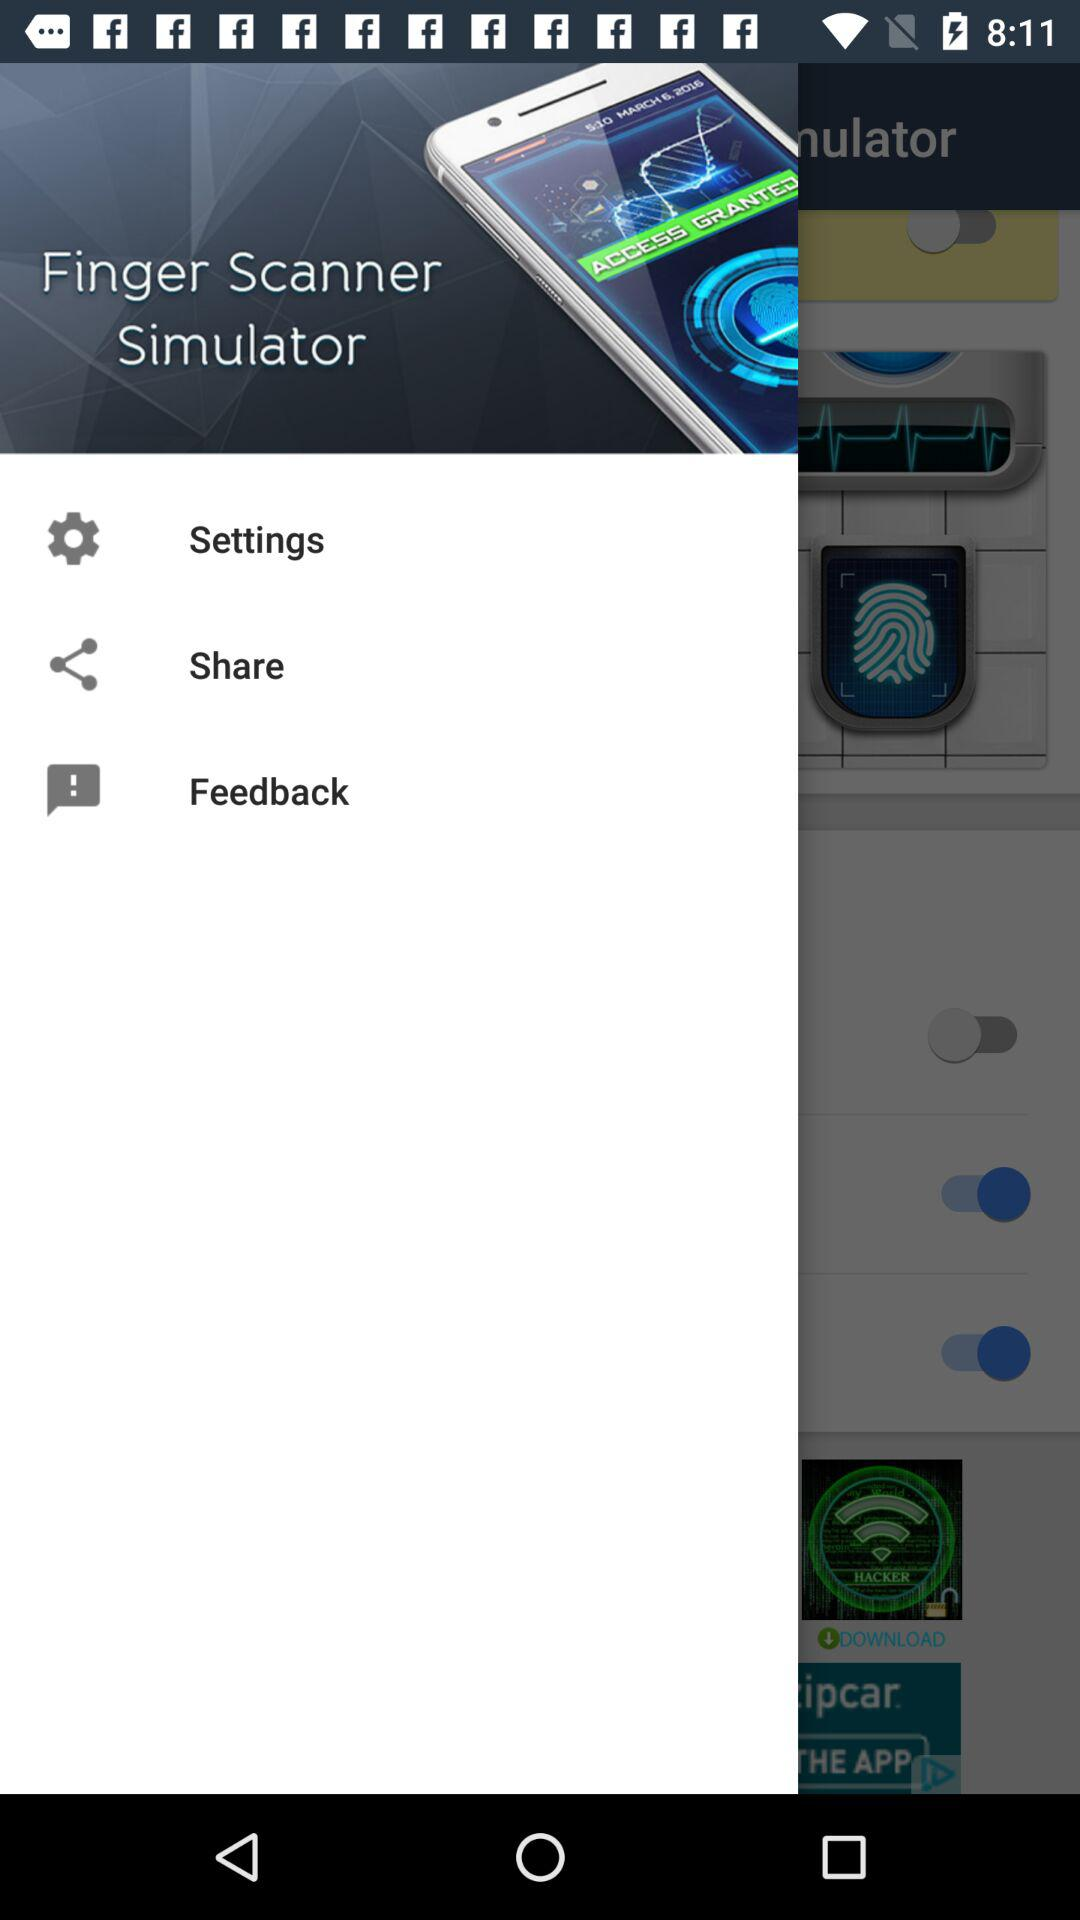How many switches are there in the screenshot?
Answer the question using a single word or phrase. 3 